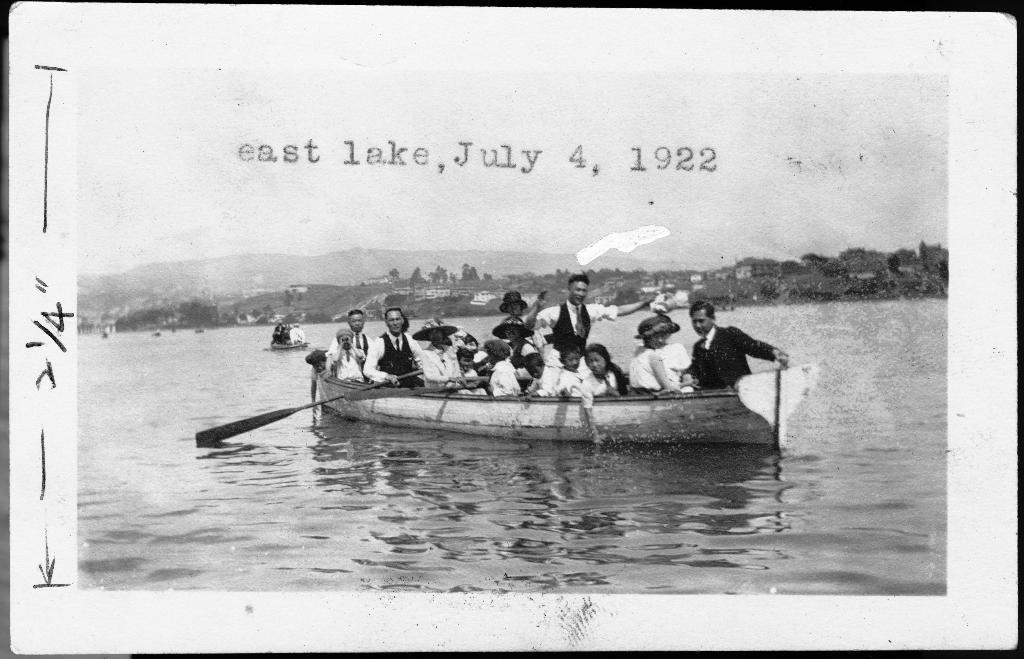Could you give a brief overview of what you see in this image? In this picture, we can see a few people sailing in boats, and we can see ground, water, buildings, trees, mountains, and we can see the sky, we can see some text on it. 